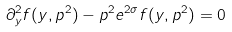Convert formula to latex. <formula><loc_0><loc_0><loc_500><loc_500>\partial _ { y } ^ { 2 } f ( y , p ^ { 2 } ) - p ^ { 2 } e ^ { 2 \sigma } f ( y , p ^ { 2 } ) = 0</formula> 